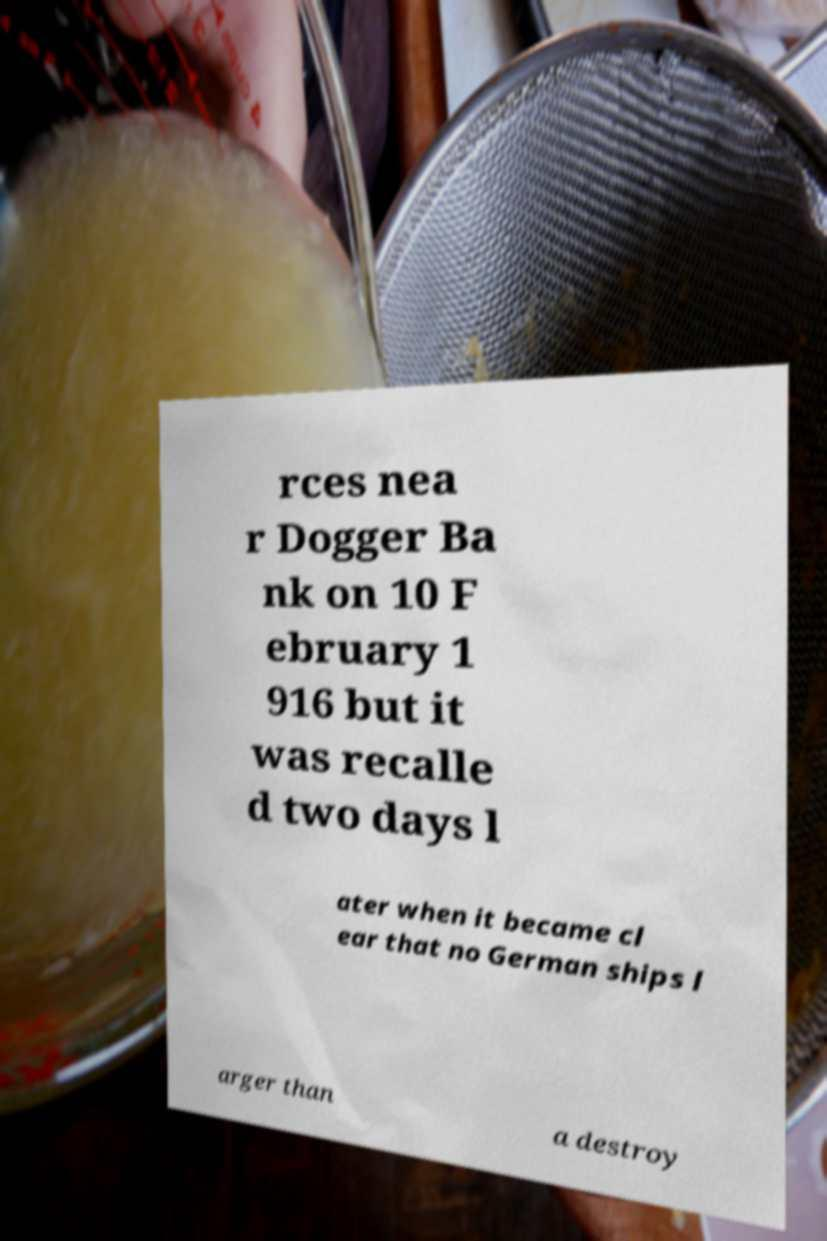For documentation purposes, I need the text within this image transcribed. Could you provide that? rces nea r Dogger Ba nk on 10 F ebruary 1 916 but it was recalle d two days l ater when it became cl ear that no German ships l arger than a destroy 